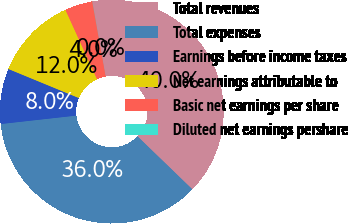<chart> <loc_0><loc_0><loc_500><loc_500><pie_chart><fcel>Total revenues<fcel>Total expenses<fcel>Earnings before income taxes<fcel>Net earnings attributable to<fcel>Basic net earnings per share<fcel>Diluted net earnings pershare<nl><fcel>40.0%<fcel>36.01%<fcel>7.99%<fcel>11.97%<fcel>4.01%<fcel>0.02%<nl></chart> 